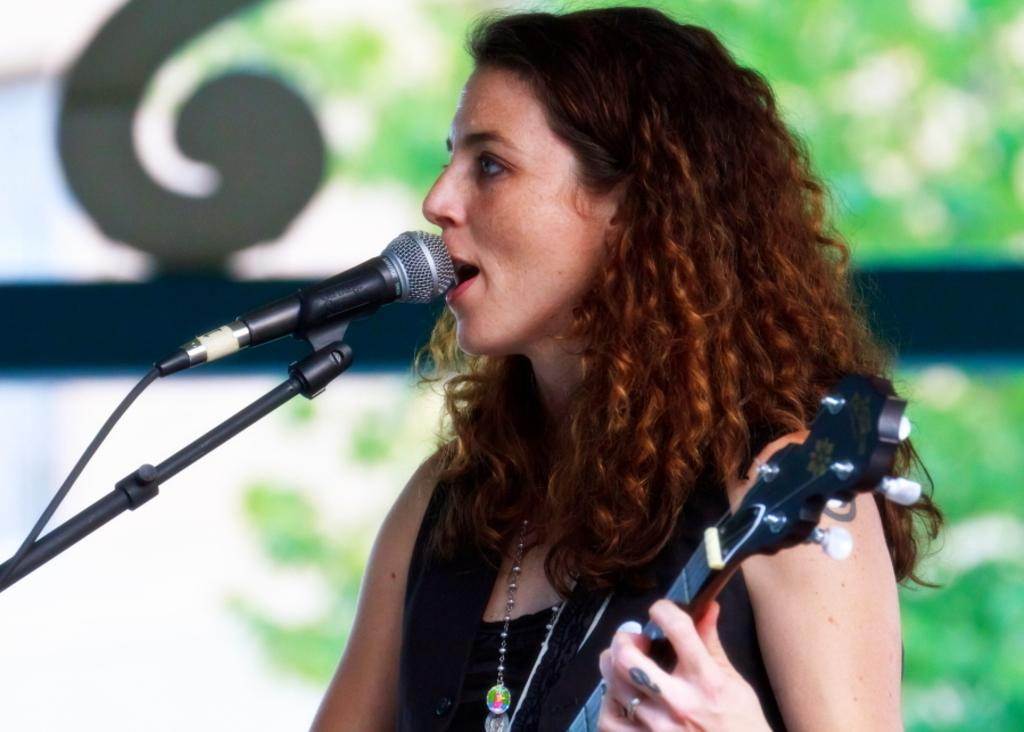Who is the main subject in the image? There is a woman in the image. What is the woman doing in the image? The woman is standing, holding a guitar, and singing. What is she using to amplify her voice? She is in front of a microphone. What can be seen in the background of the image? There are trees behind her. What type of pail is visible in the image? There is no pail present in the image. What shape is the guitar in the image? The shape of the guitar is not mentioned in the facts provided, but it is likely to be a standard guitar shape. 